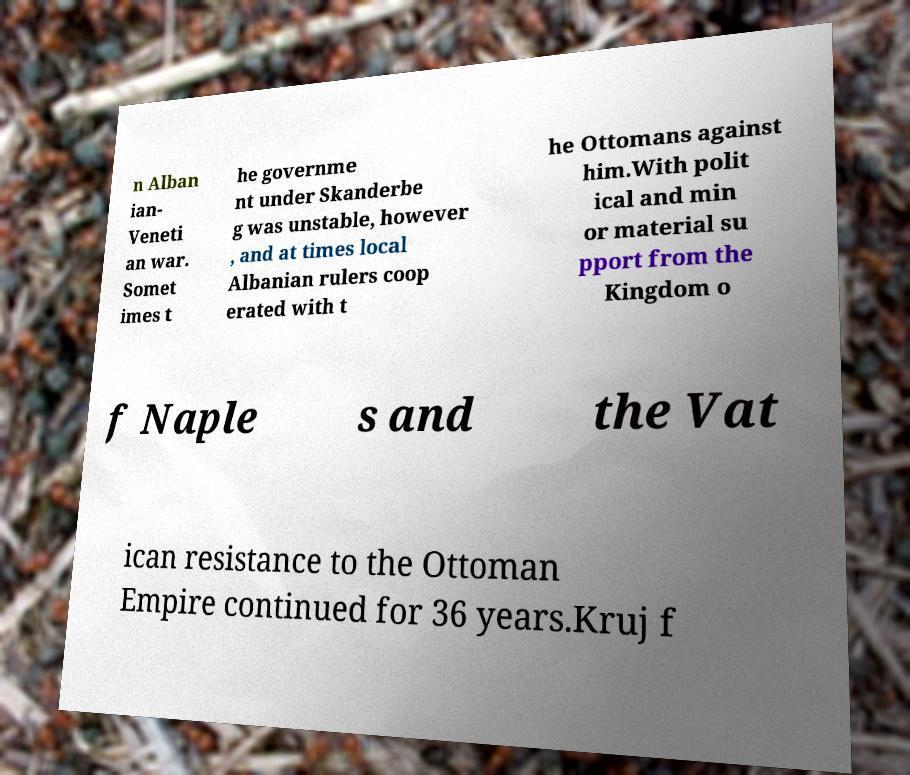Can you read and provide the text displayed in the image?This photo seems to have some interesting text. Can you extract and type it out for me? n Alban ian- Veneti an war. Somet imes t he governme nt under Skanderbe g was unstable, however , and at times local Albanian rulers coop erated with t he Ottomans against him.With polit ical and min or material su pport from the Kingdom o f Naple s and the Vat ican resistance to the Ottoman Empire continued for 36 years.Kruj f 